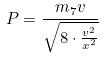Convert formula to latex. <formula><loc_0><loc_0><loc_500><loc_500>P = \frac { m _ { 7 } v } { \sqrt { 8 \cdot \frac { v ^ { 2 } } { x ^ { 2 } } } }</formula> 